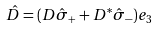<formula> <loc_0><loc_0><loc_500><loc_500>\hat { D } = ( D \hat { \sigma } _ { + } + D ^ { * } \hat { \sigma } _ { - } ) { e } _ { 3 }</formula> 